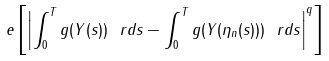<formula> <loc_0><loc_0><loc_500><loc_500>\ e \left [ \left | \int _ { 0 } ^ { T } g ( Y ( s ) ) \ r d s - \int _ { 0 } ^ { T } g ( Y ( \eta _ { n } ( s ) ) ) \ r d s \right | ^ { q } \right ]</formula> 